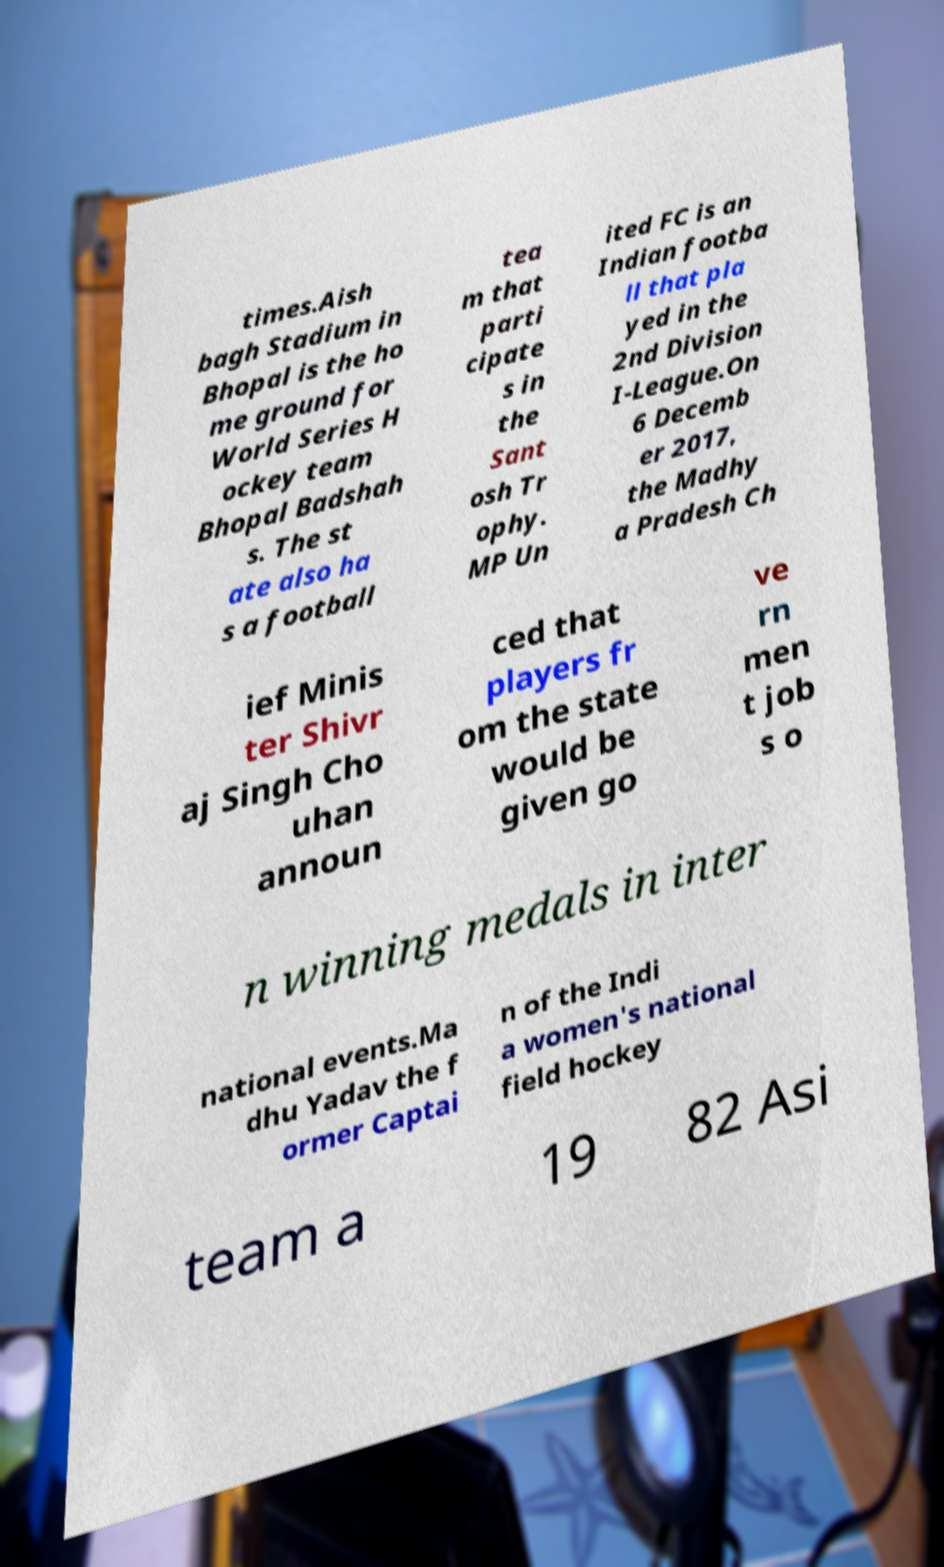Please identify and transcribe the text found in this image. times.Aish bagh Stadium in Bhopal is the ho me ground for World Series H ockey team Bhopal Badshah s. The st ate also ha s a football tea m that parti cipate s in the Sant osh Tr ophy. MP Un ited FC is an Indian footba ll that pla yed in the 2nd Division I-League.On 6 Decemb er 2017, the Madhy a Pradesh Ch ief Minis ter Shivr aj Singh Cho uhan announ ced that players fr om the state would be given go ve rn men t job s o n winning medals in inter national events.Ma dhu Yadav the f ormer Captai n of the Indi a women's national field hockey team a 19 82 Asi 